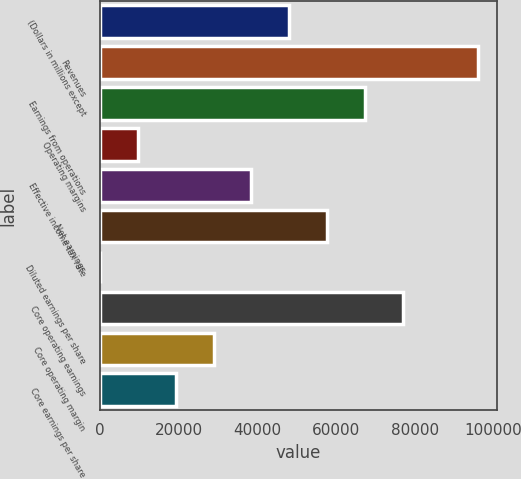<chart> <loc_0><loc_0><loc_500><loc_500><bar_chart><fcel>(Dollars in millions except<fcel>Revenues<fcel>Earnings from operations<fcel>Operating margins<fcel>Effective income tax rate<fcel>Net earnings<fcel>Diluted earnings per share<fcel>Core operating earnings<fcel>Core operating margin<fcel>Core earnings per share<nl><fcel>48060.7<fcel>96114<fcel>67282.1<fcel>9618.1<fcel>38450.1<fcel>57671.4<fcel>7.44<fcel>76892.7<fcel>28839.4<fcel>19228.8<nl></chart> 